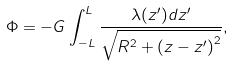<formula> <loc_0><loc_0><loc_500><loc_500>\Phi = - G \int _ { - L } ^ { L } \frac { \lambda ( z ^ { \prime } ) d z ^ { \prime } } { \sqrt { R ^ { 2 } + \left ( z - z ^ { \prime } \right ) ^ { 2 } } } ,</formula> 